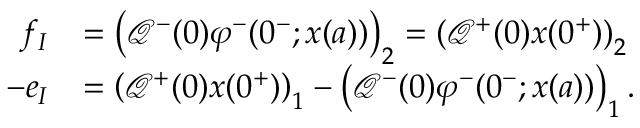Convert formula to latex. <formula><loc_0><loc_0><loc_500><loc_500>\begin{array} { r l } { f _ { I } } & { = \left ( \mathcal { Q } ^ { - } ( 0 ) \varphi ^ { - } ( 0 ^ { - } ; x ( a ) ) \right ) _ { 2 } = \left ( \mathcal { Q } ^ { + } ( 0 ) x ( 0 ^ { + } ) \right ) _ { 2 } } \\ { - e _ { I } } & { = \left ( \mathcal { Q } ^ { + } ( 0 ) x ( 0 ^ { + } ) \right ) _ { 1 } - \left ( \mathcal { Q } ^ { - } ( 0 ) \varphi ^ { - } ( 0 ^ { - } ; x ( a ) ) \right ) _ { 1 } . } \end{array}</formula> 